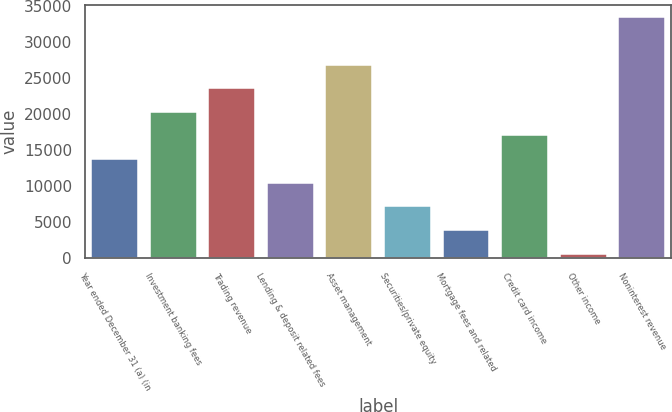<chart> <loc_0><loc_0><loc_500><loc_500><bar_chart><fcel>Year ended December 31 (a) (in<fcel>Investment banking fees<fcel>Trading revenue<fcel>Lending & deposit related fees<fcel>Asset management<fcel>Securities/private equity<fcel>Mortgage fees and related<fcel>Credit card income<fcel>Other income<fcel>Noninterest revenue<nl><fcel>13714.2<fcel>20270.8<fcel>23549.1<fcel>10435.9<fcel>26827.4<fcel>7157.6<fcel>3879.3<fcel>16992.5<fcel>601<fcel>33384<nl></chart> 